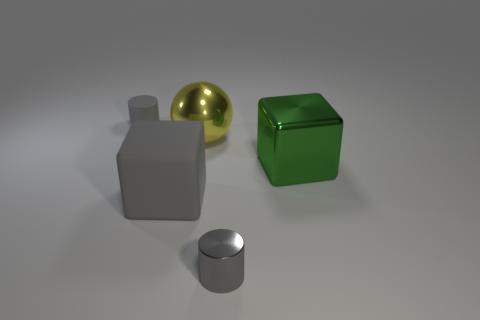Add 5 tiny gray objects. How many objects exist? 10 Subtract all cylinders. How many objects are left? 3 Subtract all metal spheres. Subtract all green things. How many objects are left? 3 Add 1 metallic cylinders. How many metallic cylinders are left? 2 Add 1 gray rubber cubes. How many gray rubber cubes exist? 2 Subtract 1 green cubes. How many objects are left? 4 